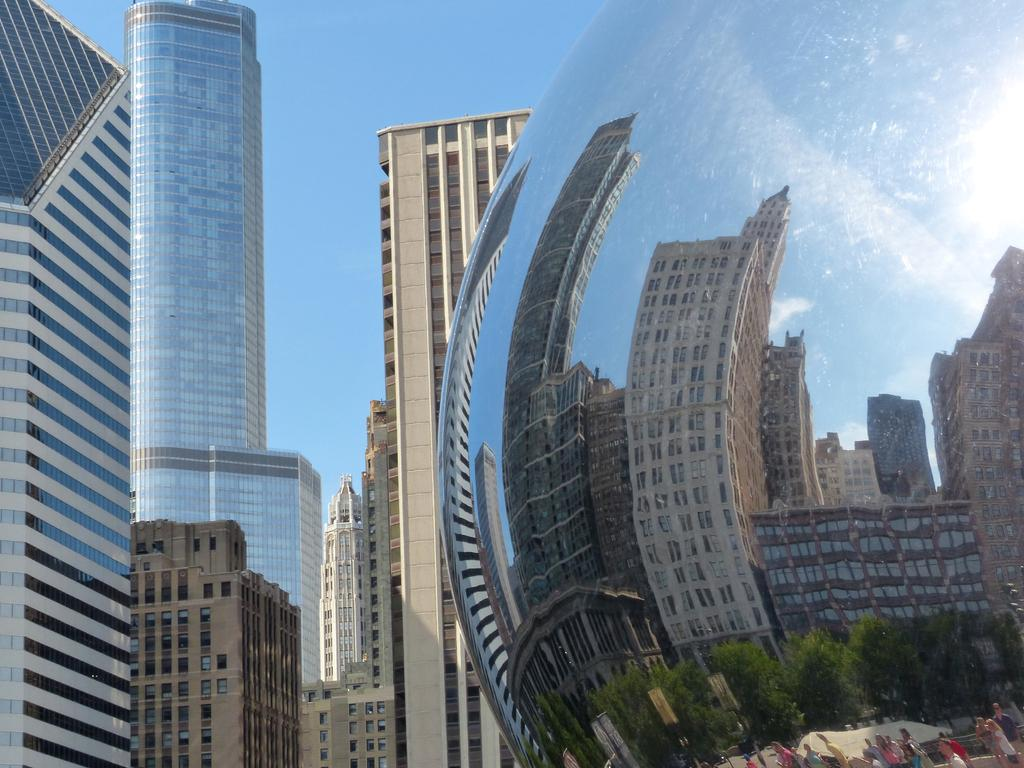What type of surface is present in the image? There is a metal surface in the image. What does the metal surface reflect? The metal surface reflects buildings, trees, and persons. What can be seen in the background of the image? There are buildings and the sky visible in the background of the image. What type of art can be seen in the image? There is no art present in the image; it features a metal surface reflecting buildings, trees, and persons. 